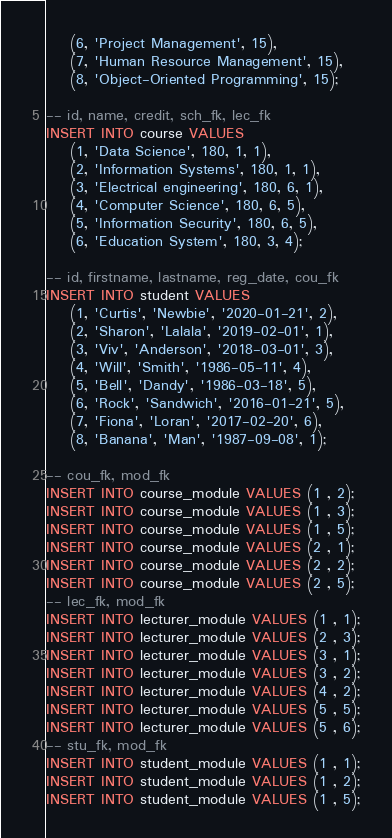<code> <loc_0><loc_0><loc_500><loc_500><_SQL_>    (6, 'Project Management', 15),
    (7, 'Human Resource Management', 15),
    (8, 'Object-Oriented Programming', 15);

-- id, name, credit, sch_fk, lec_fk
INSERT INTO course VALUES
    (1, 'Data Science', 180, 1, 1),
    (2, 'Information Systems', 180, 1, 1),
    (3, 'Electrical engineering', 180, 6, 1),
    (4, 'Computer Science', 180, 6, 5),
    (5, 'Information Security', 180, 6, 5),
    (6, 'Education System', 180, 3, 4);

-- id, firstname, lastname, reg_date, cou_fk
INSERT INTO student VALUES 
    (1, 'Curtis', 'Newbie', '2020-01-21', 2),
    (2, 'Sharon', 'Lalala', '2019-02-01', 1),
    (3, 'Viv', 'Anderson', '2018-03-01', 3),
    (4, 'Will', 'Smith', '1986-05-11', 4),
    (5, 'Bell', 'Dandy', '1986-03-18', 5),
    (6, 'Rock', 'Sandwich', '2016-01-21', 5),
    (7, 'Fiona', 'Loran', '2017-02-20', 6),
    (8, 'Banana', 'Man', '1987-09-08', 1);

-- cou_fk, mod_fk
INSERT INTO course_module VALUES (1 , 2);
INSERT INTO course_module VALUES (1 , 3);
INSERT INTO course_module VALUES (1 , 5);
INSERT INTO course_module VALUES (2 , 1);
INSERT INTO course_module VALUES (2 , 2);
INSERT INTO course_module VALUES (2 , 5);
-- lec_fk, mod_fk
INSERT INTO lecturer_module VALUES (1 , 1);
INSERT INTO lecturer_module VALUES (2 , 3);
INSERT INTO lecturer_module VALUES (3 , 1);
INSERT INTO lecturer_module VALUES (3 , 2);
INSERT INTO lecturer_module VALUES (4 , 2);
INSERT INTO lecturer_module VALUES (5 , 5);
INSERT INTO lecturer_module VALUES (5 , 6);
-- stu_fk, mod_fk
INSERT INTO student_module VALUES (1 , 1);
INSERT INTO student_module VALUES (1 , 2);
INSERT INTO student_module VALUES (1 , 5);
</code> 